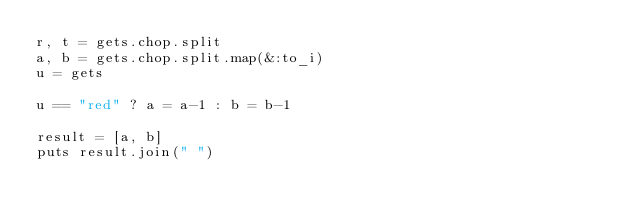Convert code to text. <code><loc_0><loc_0><loc_500><loc_500><_Ruby_>r, t = gets.chop.split
a, b = gets.chop.split.map(&:to_i)
u = gets
 
u == "red" ? a = a-1 : b = b-1
 
result = [a, b]
puts result.join(" ")</code> 